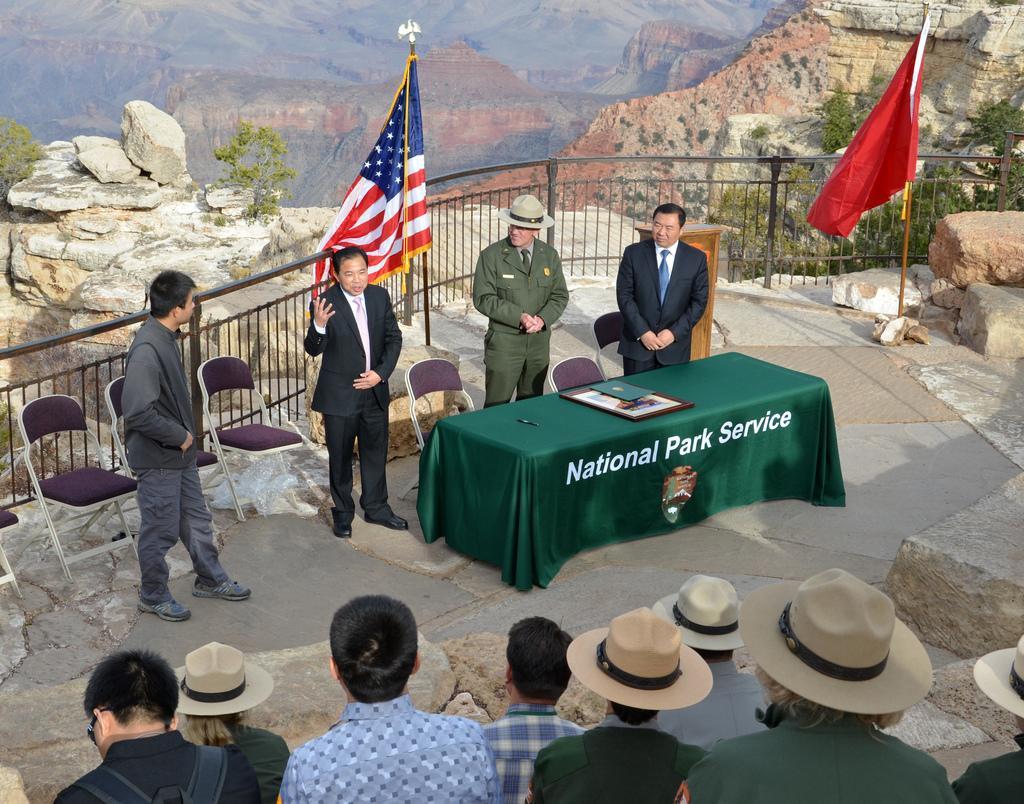Please provide a concise description of this image. There is a group of people. Some people are standing on some people are wearing hat. There is a table. There is a photo frame on a table. We can see in the background there is a mountain tree,and flag. 